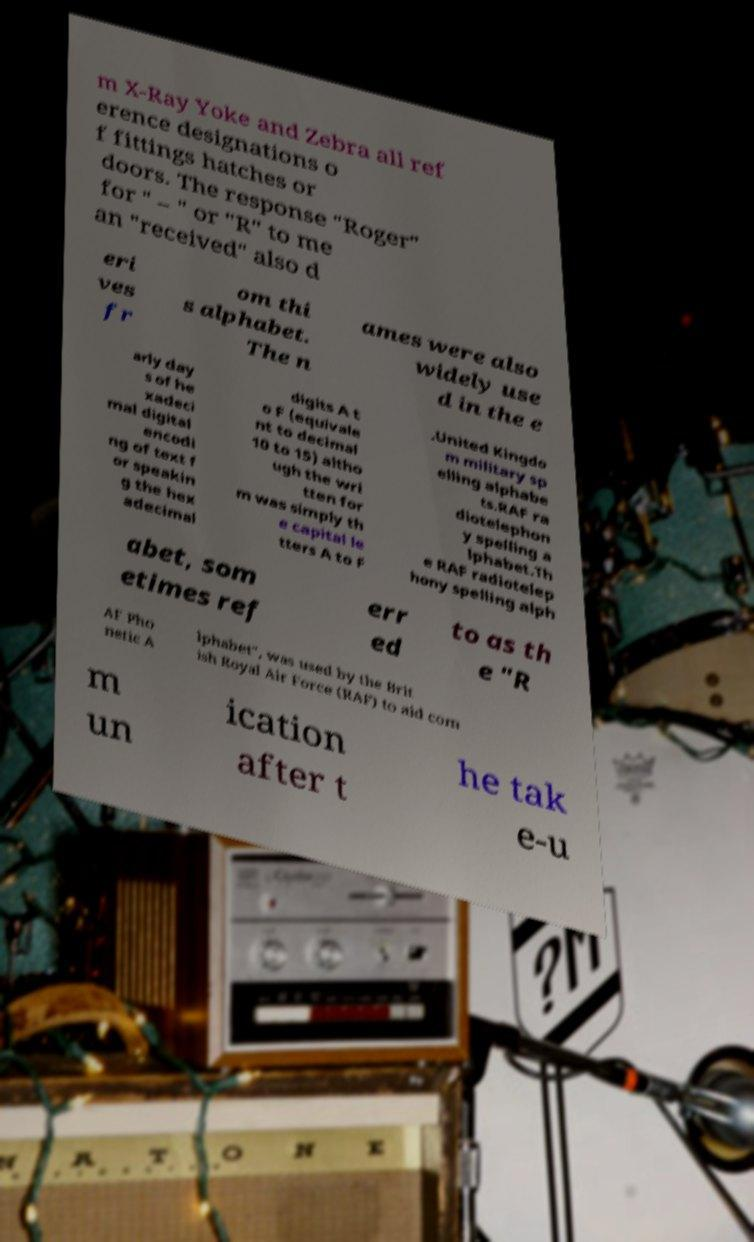Could you extract and type out the text from this image? m X-Ray Yoke and Zebra all ref erence designations o f fittings hatches or doors. The response "Roger" for " – " or "R" to me an "received" also d eri ves fr om thi s alphabet. The n ames were also widely use d in the e arly day s of he xadeci mal digital encodi ng of text f or speakin g the hex adecimal digits A t o F (equivale nt to decimal 10 to 15) altho ugh the wri tten for m was simply th e capital le tters A to F .United Kingdo m military sp elling alphabe ts.RAF ra diotelephon y spelling a lphabet.Th e RAF radiotelep hony spelling alph abet, som etimes ref err ed to as th e "R AF Pho netic A lphabet", was used by the Brit ish Royal Air Force (RAF) to aid com m un ication after t he tak e-u 